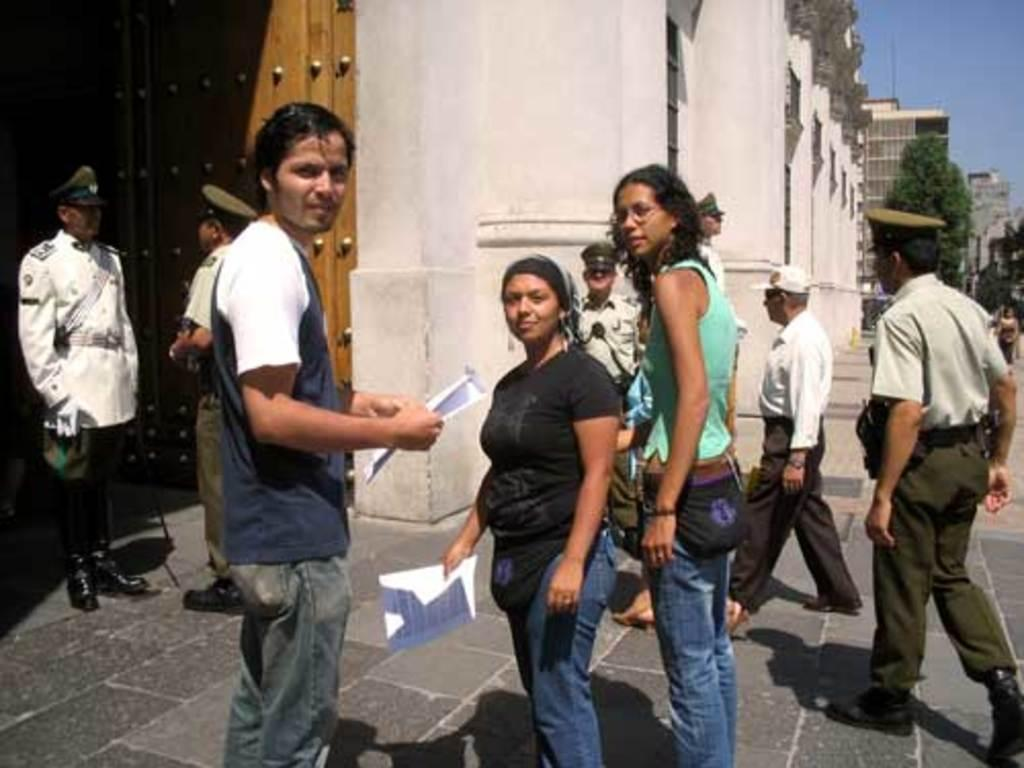What are the people in the image doing? The people in the image are standing and walking. What are the people holding in the image? The people are holding papers. What can be seen in the background of the image? There are trees and buildings visible in the background of the image. What part of the sky is visible in the image? The sky is visible in the top right corner of the image. What type of thread is being used to sew the people's papers together in the image? There is no thread or sewing activity present in the image; the people are simply holding papers. 